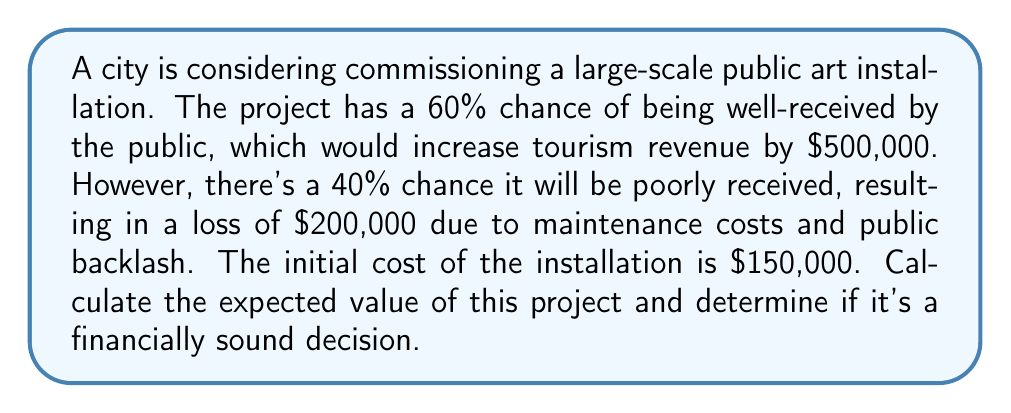Provide a solution to this math problem. To solve this problem, we'll use the concept of expected value from decision theory. Let's break it down step-by-step:

1) First, let's define our outcomes:
   - Positive outcome (60% chance): $500,000 gain
   - Negative outcome (40% chance): $200,000 loss

2) The expected value (EV) is calculated by multiplying each possible outcome by its probability and then summing these products:

   $$ EV = (P_{positive} \times V_{positive}) + (P_{negative} \times V_{negative}) $$

   Where P is probability and V is value.

3) Let's plug in our values:

   $$ EV = (0.60 \times \$500,000) + (0.40 \times (-\$200,000)) $$

4) Simplify:

   $$ EV = \$300,000 - \$80,000 = \$220,000 $$

5) However, we need to account for the initial cost of $150,000:

   $$ Net\;EV = \$220,000 - \$150,000 = \$70,000 $$

6) Since the Net Expected Value is positive, this project is expected to be financially beneficial.
Answer: The expected value of the project is $70,000. Given that this value is positive, it would be considered a financially sound decision to proceed with the art installation. 